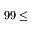Convert formula to latex. <formula><loc_0><loc_0><loc_500><loc_500>9 9 \leq</formula> 